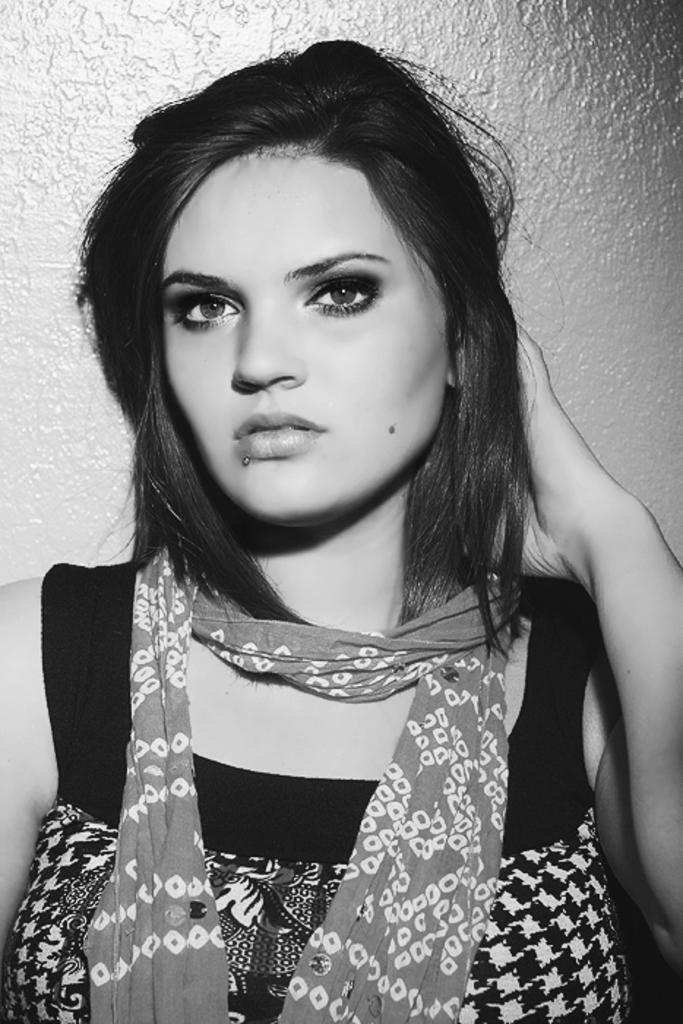Who is the main subject in the image? There is a woman in the image. What is the woman wearing? The woman is wearing clothes and a scarf. What is the color scheme of the image? The image is black and white. Can you tell me how many times the woman attempts to shake hands in the image? There is no indication of the woman attempting to shake hands in the image, as it is a black and white image of a woman wearing clothes and a scarf. 